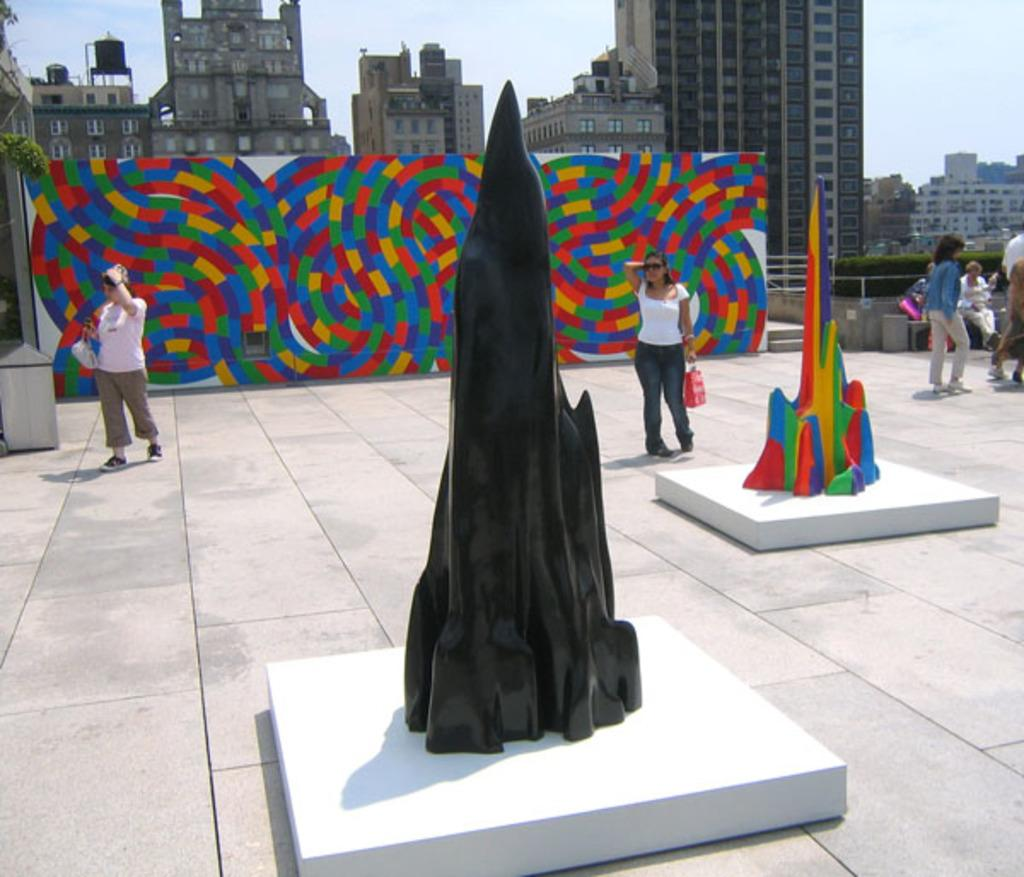What can be observed about the colors of the objects in the image? There are objects in different colors in the image. What else can be seen in the image besides the objects? There are people standing in the image. What is visible in the background of the image? There are buildings in the background of the image. What type of office can be seen in the image? There is no office present in the image. How many feet are visible in the image? There is no mention of feet in the image, so it cannot be determined how many are visible. 